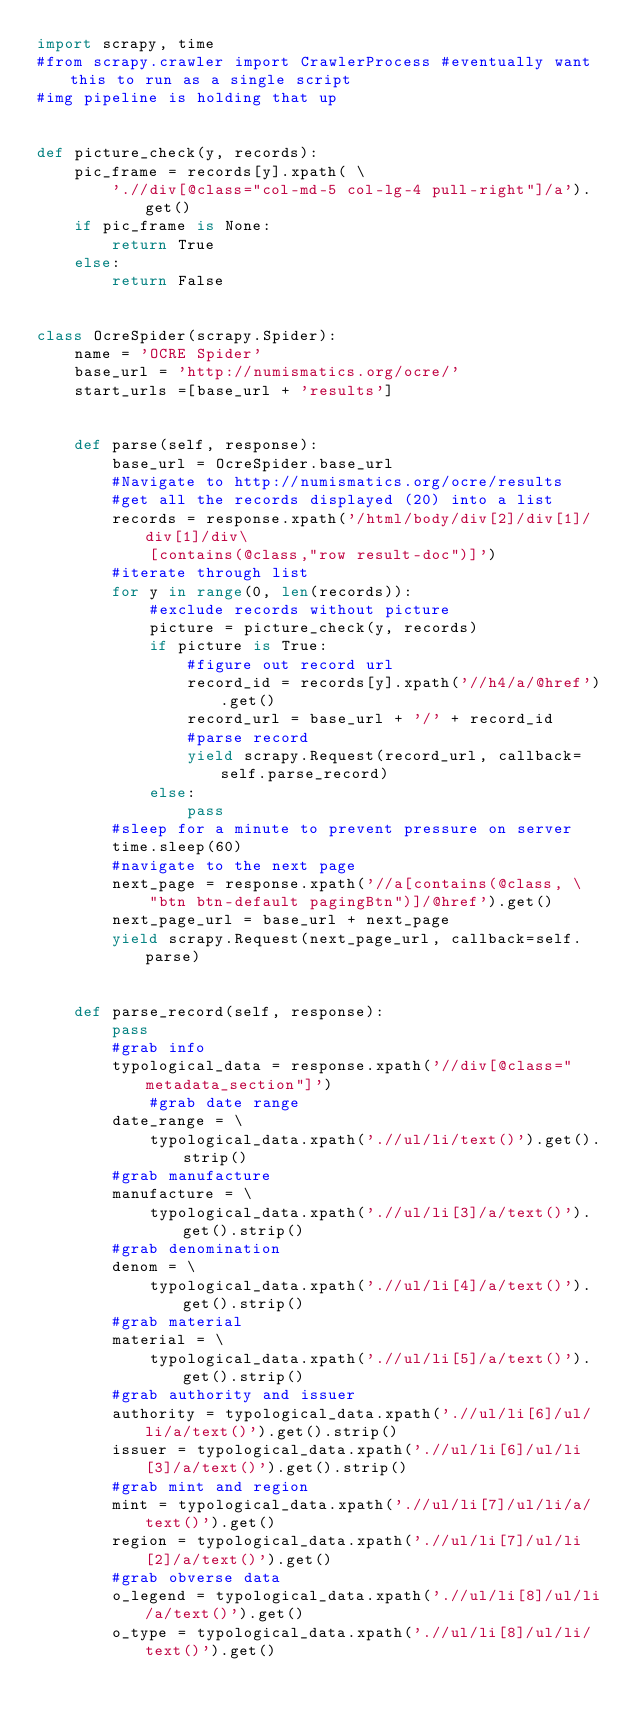<code> <loc_0><loc_0><loc_500><loc_500><_Python_>import scrapy, time
#from scrapy.crawler import CrawlerProcess #eventually want this to run as a single script
#img pipeline is holding that up


def picture_check(y, records):
    pic_frame = records[y].xpath( \
        './/div[@class="col-md-5 col-lg-4 pull-right"]/a').get()
    if pic_frame is None:
        return True
    else: 
        return False


class OcreSpider(scrapy.Spider):
    name = 'OCRE Spider'
    base_url = 'http://numismatics.org/ocre/'
    start_urls =[base_url + 'results']


    def parse(self, response):
        base_url = OcreSpider.base_url
        #Navigate to http://numismatics.org/ocre/results
        #get all the records displayed (20) into a list
        records = response.xpath('/html/body/div[2]/div[1]/div[1]/div\
            [contains(@class,"row result-doc")]')
        #iterate through list
        for y in range(0, len(records)):
            #exclude records without picture
            picture = picture_check(y, records)
            if picture is True:
                #figure out record url
                record_id = records[y].xpath('//h4/a/@href').get()
                record_url = base_url + '/' + record_id
                #parse record
                yield scrapy.Request(record_url, callback=self.parse_record)
            else:
                pass
        #sleep for a minute to prevent pressure on server
        time.sleep(60)
        #navigate to the next page
        next_page = response.xpath('//a[contains(@class, \
            "btn btn-default pagingBtn")]/@href').get()
        next_page_url = base_url + next_page
        yield scrapy.Request(next_page_url, callback=self.parse)


    def parse_record(self, response):
        pass
        #grab info
        typological_data = response.xpath('//div[@class="metadata_section"]')
            #grab date range
        date_range = \
            typological_data.xpath('.//ul/li/text()').get().strip()
        #grab manufacture
        manufacture = \
            typological_data.xpath('.//ul/li[3]/a/text()').get().strip()
        #grab denomination
        denom = \
            typological_data.xpath('.//ul/li[4]/a/text()').get().strip()
        #grab material
        material = \
            typological_data.xpath('.//ul/li[5]/a/text()').get().strip()
        #grab authority and issuer
        authority = typological_data.xpath('.//ul/li[6]/ul/li/a/text()').get().strip()
        issuer = typological_data.xpath('.//ul/li[6]/ul/li[3]/a/text()').get().strip()
        #grab mint and region
        mint = typological_data.xpath('.//ul/li[7]/ul/li/a/text()').get()
        region = typological_data.xpath('.//ul/li[7]/ul/li[2]/a/text()').get()
        #grab obverse data
        o_legend = typological_data.xpath('.//ul/li[8]/ul/li/a/text()').get()
        o_type = typological_data.xpath('.//ul/li[8]/ul/li/text()').get()</code> 